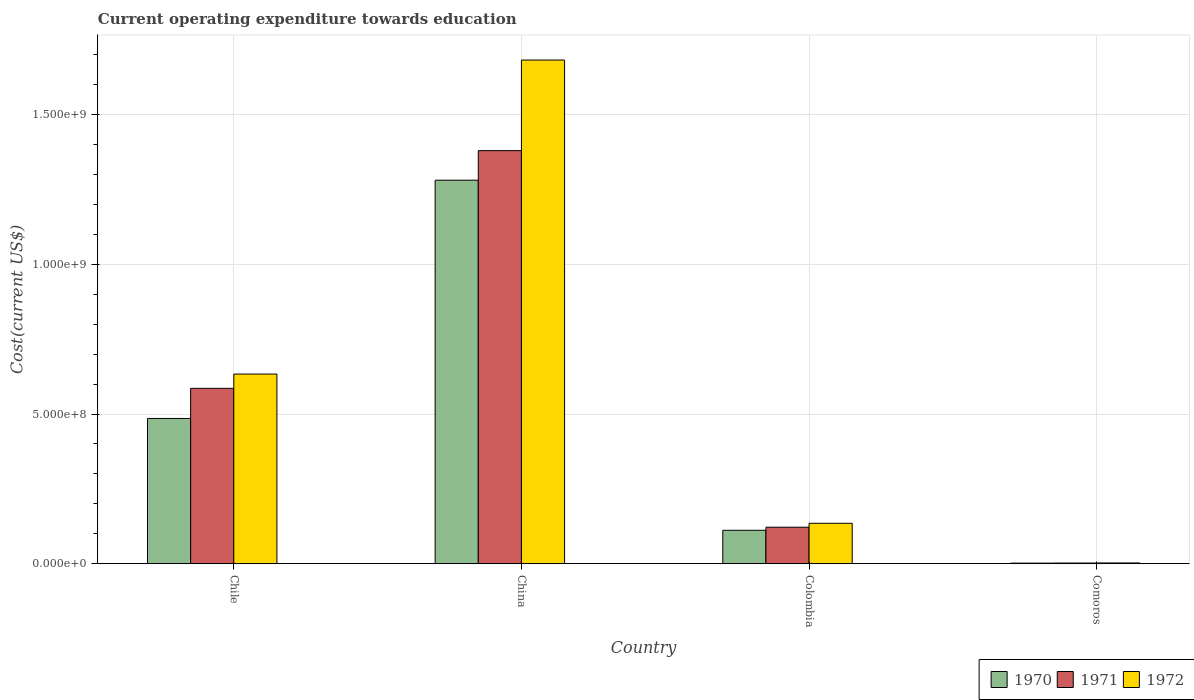In how many cases, is the number of bars for a given country not equal to the number of legend labels?
Ensure brevity in your answer.  0. What is the expenditure towards education in 1971 in Chile?
Make the answer very short. 5.86e+08. Across all countries, what is the maximum expenditure towards education in 1971?
Provide a short and direct response. 1.38e+09. Across all countries, what is the minimum expenditure towards education in 1972?
Your response must be concise. 2.64e+06. In which country was the expenditure towards education in 1972 minimum?
Your answer should be very brief. Comoros. What is the total expenditure towards education in 1972 in the graph?
Provide a succinct answer. 2.45e+09. What is the difference between the expenditure towards education in 1972 in China and that in Comoros?
Offer a terse response. 1.68e+09. What is the difference between the expenditure towards education in 1972 in Colombia and the expenditure towards education in 1970 in Comoros?
Offer a very short reply. 1.33e+08. What is the average expenditure towards education in 1970 per country?
Your answer should be compact. 4.70e+08. What is the difference between the expenditure towards education of/in 1971 and expenditure towards education of/in 1972 in Comoros?
Your answer should be very brief. -3.01e+05. What is the ratio of the expenditure towards education in 1971 in Chile to that in Comoros?
Provide a short and direct response. 250.81. What is the difference between the highest and the second highest expenditure towards education in 1971?
Offer a terse response. -7.94e+08. What is the difference between the highest and the lowest expenditure towards education in 1970?
Keep it short and to the point. 1.28e+09. In how many countries, is the expenditure towards education in 1971 greater than the average expenditure towards education in 1971 taken over all countries?
Provide a short and direct response. 2. Is the sum of the expenditure towards education in 1970 in Chile and China greater than the maximum expenditure towards education in 1972 across all countries?
Make the answer very short. Yes. What does the 1st bar from the right in Comoros represents?
Provide a succinct answer. 1972. Is it the case that in every country, the sum of the expenditure towards education in 1970 and expenditure towards education in 1972 is greater than the expenditure towards education in 1971?
Your response must be concise. Yes. How many bars are there?
Your answer should be very brief. 12. How many countries are there in the graph?
Your answer should be compact. 4. What is the difference between two consecutive major ticks on the Y-axis?
Make the answer very short. 5.00e+08. Does the graph contain any zero values?
Give a very brief answer. No. Where does the legend appear in the graph?
Provide a succinct answer. Bottom right. How many legend labels are there?
Make the answer very short. 3. What is the title of the graph?
Keep it short and to the point. Current operating expenditure towards education. Does "1972" appear as one of the legend labels in the graph?
Ensure brevity in your answer.  Yes. What is the label or title of the X-axis?
Your answer should be very brief. Country. What is the label or title of the Y-axis?
Your answer should be compact. Cost(current US$). What is the Cost(current US$) in 1970 in Chile?
Offer a terse response. 4.85e+08. What is the Cost(current US$) of 1971 in Chile?
Your answer should be very brief. 5.86e+08. What is the Cost(current US$) of 1972 in Chile?
Ensure brevity in your answer.  6.34e+08. What is the Cost(current US$) in 1970 in China?
Provide a succinct answer. 1.28e+09. What is the Cost(current US$) in 1971 in China?
Your answer should be compact. 1.38e+09. What is the Cost(current US$) in 1972 in China?
Provide a short and direct response. 1.68e+09. What is the Cost(current US$) in 1970 in Colombia?
Keep it short and to the point. 1.12e+08. What is the Cost(current US$) of 1971 in Colombia?
Your answer should be compact. 1.22e+08. What is the Cost(current US$) in 1972 in Colombia?
Offer a terse response. 1.35e+08. What is the Cost(current US$) of 1970 in Comoros?
Offer a terse response. 1.98e+06. What is the Cost(current US$) in 1971 in Comoros?
Ensure brevity in your answer.  2.34e+06. What is the Cost(current US$) of 1972 in Comoros?
Provide a succinct answer. 2.64e+06. Across all countries, what is the maximum Cost(current US$) in 1970?
Your answer should be compact. 1.28e+09. Across all countries, what is the maximum Cost(current US$) in 1971?
Keep it short and to the point. 1.38e+09. Across all countries, what is the maximum Cost(current US$) of 1972?
Your response must be concise. 1.68e+09. Across all countries, what is the minimum Cost(current US$) in 1970?
Ensure brevity in your answer.  1.98e+06. Across all countries, what is the minimum Cost(current US$) of 1971?
Your answer should be very brief. 2.34e+06. Across all countries, what is the minimum Cost(current US$) of 1972?
Make the answer very short. 2.64e+06. What is the total Cost(current US$) in 1970 in the graph?
Make the answer very short. 1.88e+09. What is the total Cost(current US$) of 1971 in the graph?
Offer a very short reply. 2.09e+09. What is the total Cost(current US$) in 1972 in the graph?
Keep it short and to the point. 2.45e+09. What is the difference between the Cost(current US$) of 1970 in Chile and that in China?
Give a very brief answer. -7.96e+08. What is the difference between the Cost(current US$) of 1971 in Chile and that in China?
Make the answer very short. -7.94e+08. What is the difference between the Cost(current US$) of 1972 in Chile and that in China?
Offer a very short reply. -1.05e+09. What is the difference between the Cost(current US$) of 1970 in Chile and that in Colombia?
Offer a terse response. 3.74e+08. What is the difference between the Cost(current US$) in 1971 in Chile and that in Colombia?
Offer a very short reply. 4.64e+08. What is the difference between the Cost(current US$) in 1972 in Chile and that in Colombia?
Give a very brief answer. 4.99e+08. What is the difference between the Cost(current US$) in 1970 in Chile and that in Comoros?
Your answer should be compact. 4.83e+08. What is the difference between the Cost(current US$) of 1971 in Chile and that in Comoros?
Offer a terse response. 5.84e+08. What is the difference between the Cost(current US$) of 1972 in Chile and that in Comoros?
Offer a terse response. 6.31e+08. What is the difference between the Cost(current US$) of 1970 in China and that in Colombia?
Provide a succinct answer. 1.17e+09. What is the difference between the Cost(current US$) of 1971 in China and that in Colombia?
Give a very brief answer. 1.26e+09. What is the difference between the Cost(current US$) of 1972 in China and that in Colombia?
Provide a succinct answer. 1.55e+09. What is the difference between the Cost(current US$) of 1970 in China and that in Comoros?
Offer a terse response. 1.28e+09. What is the difference between the Cost(current US$) in 1971 in China and that in Comoros?
Offer a very short reply. 1.38e+09. What is the difference between the Cost(current US$) in 1972 in China and that in Comoros?
Your response must be concise. 1.68e+09. What is the difference between the Cost(current US$) of 1970 in Colombia and that in Comoros?
Keep it short and to the point. 1.10e+08. What is the difference between the Cost(current US$) in 1971 in Colombia and that in Comoros?
Offer a very short reply. 1.20e+08. What is the difference between the Cost(current US$) of 1972 in Colombia and that in Comoros?
Give a very brief answer. 1.32e+08. What is the difference between the Cost(current US$) in 1970 in Chile and the Cost(current US$) in 1971 in China?
Keep it short and to the point. -8.95e+08. What is the difference between the Cost(current US$) of 1970 in Chile and the Cost(current US$) of 1972 in China?
Ensure brevity in your answer.  -1.20e+09. What is the difference between the Cost(current US$) in 1971 in Chile and the Cost(current US$) in 1972 in China?
Keep it short and to the point. -1.10e+09. What is the difference between the Cost(current US$) in 1970 in Chile and the Cost(current US$) in 1971 in Colombia?
Ensure brevity in your answer.  3.63e+08. What is the difference between the Cost(current US$) of 1970 in Chile and the Cost(current US$) of 1972 in Colombia?
Your answer should be compact. 3.50e+08. What is the difference between the Cost(current US$) of 1971 in Chile and the Cost(current US$) of 1972 in Colombia?
Ensure brevity in your answer.  4.51e+08. What is the difference between the Cost(current US$) in 1970 in Chile and the Cost(current US$) in 1971 in Comoros?
Provide a short and direct response. 4.83e+08. What is the difference between the Cost(current US$) of 1970 in Chile and the Cost(current US$) of 1972 in Comoros?
Offer a terse response. 4.83e+08. What is the difference between the Cost(current US$) in 1971 in Chile and the Cost(current US$) in 1972 in Comoros?
Provide a short and direct response. 5.83e+08. What is the difference between the Cost(current US$) of 1970 in China and the Cost(current US$) of 1971 in Colombia?
Give a very brief answer. 1.16e+09. What is the difference between the Cost(current US$) of 1970 in China and the Cost(current US$) of 1972 in Colombia?
Give a very brief answer. 1.15e+09. What is the difference between the Cost(current US$) of 1971 in China and the Cost(current US$) of 1972 in Colombia?
Your response must be concise. 1.24e+09. What is the difference between the Cost(current US$) in 1970 in China and the Cost(current US$) in 1971 in Comoros?
Provide a short and direct response. 1.28e+09. What is the difference between the Cost(current US$) in 1970 in China and the Cost(current US$) in 1972 in Comoros?
Provide a short and direct response. 1.28e+09. What is the difference between the Cost(current US$) in 1971 in China and the Cost(current US$) in 1972 in Comoros?
Keep it short and to the point. 1.38e+09. What is the difference between the Cost(current US$) of 1970 in Colombia and the Cost(current US$) of 1971 in Comoros?
Provide a short and direct response. 1.09e+08. What is the difference between the Cost(current US$) of 1970 in Colombia and the Cost(current US$) of 1972 in Comoros?
Provide a short and direct response. 1.09e+08. What is the difference between the Cost(current US$) of 1971 in Colombia and the Cost(current US$) of 1972 in Comoros?
Give a very brief answer. 1.19e+08. What is the average Cost(current US$) of 1970 per country?
Provide a succinct answer. 4.70e+08. What is the average Cost(current US$) of 1971 per country?
Offer a terse response. 5.23e+08. What is the average Cost(current US$) of 1972 per country?
Provide a short and direct response. 6.13e+08. What is the difference between the Cost(current US$) of 1970 and Cost(current US$) of 1971 in Chile?
Your answer should be compact. -1.01e+08. What is the difference between the Cost(current US$) of 1970 and Cost(current US$) of 1972 in Chile?
Make the answer very short. -1.48e+08. What is the difference between the Cost(current US$) in 1971 and Cost(current US$) in 1972 in Chile?
Offer a terse response. -4.77e+07. What is the difference between the Cost(current US$) in 1970 and Cost(current US$) in 1971 in China?
Your answer should be compact. -9.88e+07. What is the difference between the Cost(current US$) in 1970 and Cost(current US$) in 1972 in China?
Make the answer very short. -4.01e+08. What is the difference between the Cost(current US$) in 1971 and Cost(current US$) in 1972 in China?
Provide a short and direct response. -3.03e+08. What is the difference between the Cost(current US$) of 1970 and Cost(current US$) of 1971 in Colombia?
Your answer should be very brief. -1.02e+07. What is the difference between the Cost(current US$) in 1970 and Cost(current US$) in 1972 in Colombia?
Provide a short and direct response. -2.34e+07. What is the difference between the Cost(current US$) of 1971 and Cost(current US$) of 1972 in Colombia?
Provide a short and direct response. -1.32e+07. What is the difference between the Cost(current US$) in 1970 and Cost(current US$) in 1971 in Comoros?
Your response must be concise. -3.52e+05. What is the difference between the Cost(current US$) in 1970 and Cost(current US$) in 1972 in Comoros?
Provide a succinct answer. -6.53e+05. What is the difference between the Cost(current US$) of 1971 and Cost(current US$) of 1972 in Comoros?
Your answer should be compact. -3.01e+05. What is the ratio of the Cost(current US$) in 1970 in Chile to that in China?
Keep it short and to the point. 0.38. What is the ratio of the Cost(current US$) in 1971 in Chile to that in China?
Your response must be concise. 0.42. What is the ratio of the Cost(current US$) in 1972 in Chile to that in China?
Ensure brevity in your answer.  0.38. What is the ratio of the Cost(current US$) in 1970 in Chile to that in Colombia?
Offer a very short reply. 4.34. What is the ratio of the Cost(current US$) of 1971 in Chile to that in Colombia?
Your answer should be compact. 4.81. What is the ratio of the Cost(current US$) in 1972 in Chile to that in Colombia?
Your answer should be very brief. 4.69. What is the ratio of the Cost(current US$) of 1970 in Chile to that in Comoros?
Provide a succinct answer. 244.51. What is the ratio of the Cost(current US$) of 1971 in Chile to that in Comoros?
Provide a succinct answer. 250.81. What is the ratio of the Cost(current US$) of 1972 in Chile to that in Comoros?
Offer a terse response. 240.25. What is the ratio of the Cost(current US$) in 1970 in China to that in Colombia?
Your response must be concise. 11.47. What is the ratio of the Cost(current US$) of 1971 in China to that in Colombia?
Keep it short and to the point. 11.32. What is the ratio of the Cost(current US$) in 1972 in China to that in Colombia?
Give a very brief answer. 12.45. What is the ratio of the Cost(current US$) of 1970 in China to that in Comoros?
Keep it short and to the point. 645.54. What is the ratio of the Cost(current US$) in 1971 in China to that in Comoros?
Keep it short and to the point. 590.68. What is the ratio of the Cost(current US$) of 1972 in China to that in Comoros?
Keep it short and to the point. 637.94. What is the ratio of the Cost(current US$) of 1970 in Colombia to that in Comoros?
Provide a short and direct response. 56.29. What is the ratio of the Cost(current US$) of 1971 in Colombia to that in Comoros?
Keep it short and to the point. 52.19. What is the ratio of the Cost(current US$) in 1972 in Colombia to that in Comoros?
Your response must be concise. 51.22. What is the difference between the highest and the second highest Cost(current US$) in 1970?
Make the answer very short. 7.96e+08. What is the difference between the highest and the second highest Cost(current US$) in 1971?
Make the answer very short. 7.94e+08. What is the difference between the highest and the second highest Cost(current US$) of 1972?
Your response must be concise. 1.05e+09. What is the difference between the highest and the lowest Cost(current US$) of 1970?
Keep it short and to the point. 1.28e+09. What is the difference between the highest and the lowest Cost(current US$) in 1971?
Your answer should be very brief. 1.38e+09. What is the difference between the highest and the lowest Cost(current US$) of 1972?
Provide a short and direct response. 1.68e+09. 